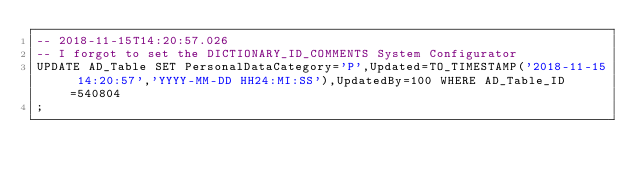<code> <loc_0><loc_0><loc_500><loc_500><_SQL_>-- 2018-11-15T14:20:57.026
-- I forgot to set the DICTIONARY_ID_COMMENTS System Configurator
UPDATE AD_Table SET PersonalDataCategory='P',Updated=TO_TIMESTAMP('2018-11-15 14:20:57','YYYY-MM-DD HH24:MI:SS'),UpdatedBy=100 WHERE AD_Table_ID=540804
;

</code> 